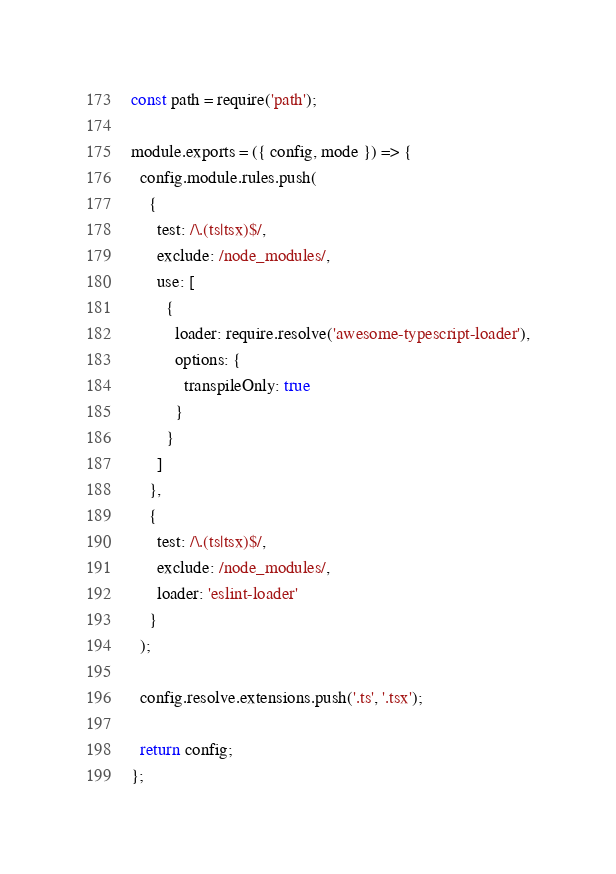Convert code to text. <code><loc_0><loc_0><loc_500><loc_500><_JavaScript_>const path = require('path');

module.exports = ({ config, mode }) => {
  config.module.rules.push(
    {
      test: /\.(ts|tsx)$/,
      exclude: /node_modules/,
      use: [
        {
          loader: require.resolve('awesome-typescript-loader'),
          options: {
            transpileOnly: true
          }
        }
      ]
    },
    {
      test: /\.(ts|tsx)$/,
      exclude: /node_modules/,
      loader: 'eslint-loader'
    }
  );

  config.resolve.extensions.push('.ts', '.tsx');

  return config;
};
</code> 